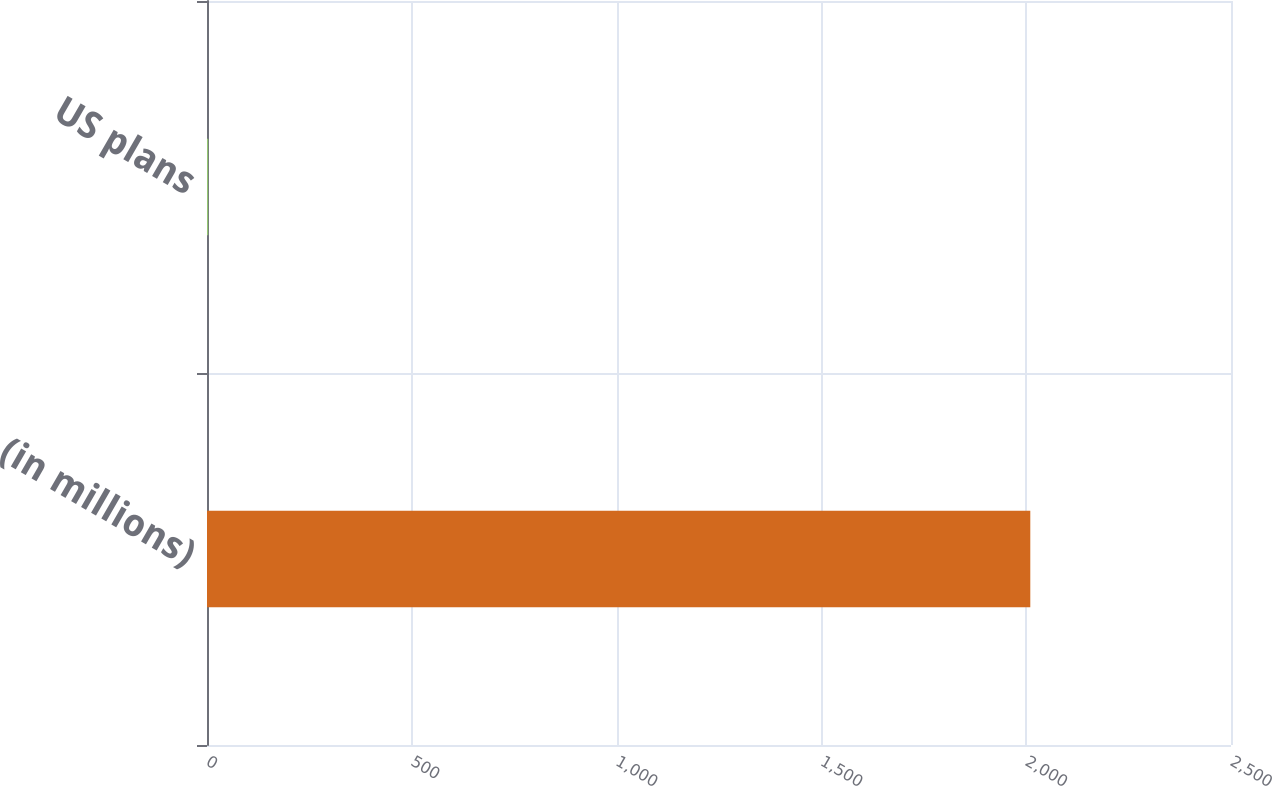Convert chart to OTSL. <chart><loc_0><loc_0><loc_500><loc_500><bar_chart><fcel>(in millions)<fcel>US plans<nl><fcel>2010<fcel>3<nl></chart> 